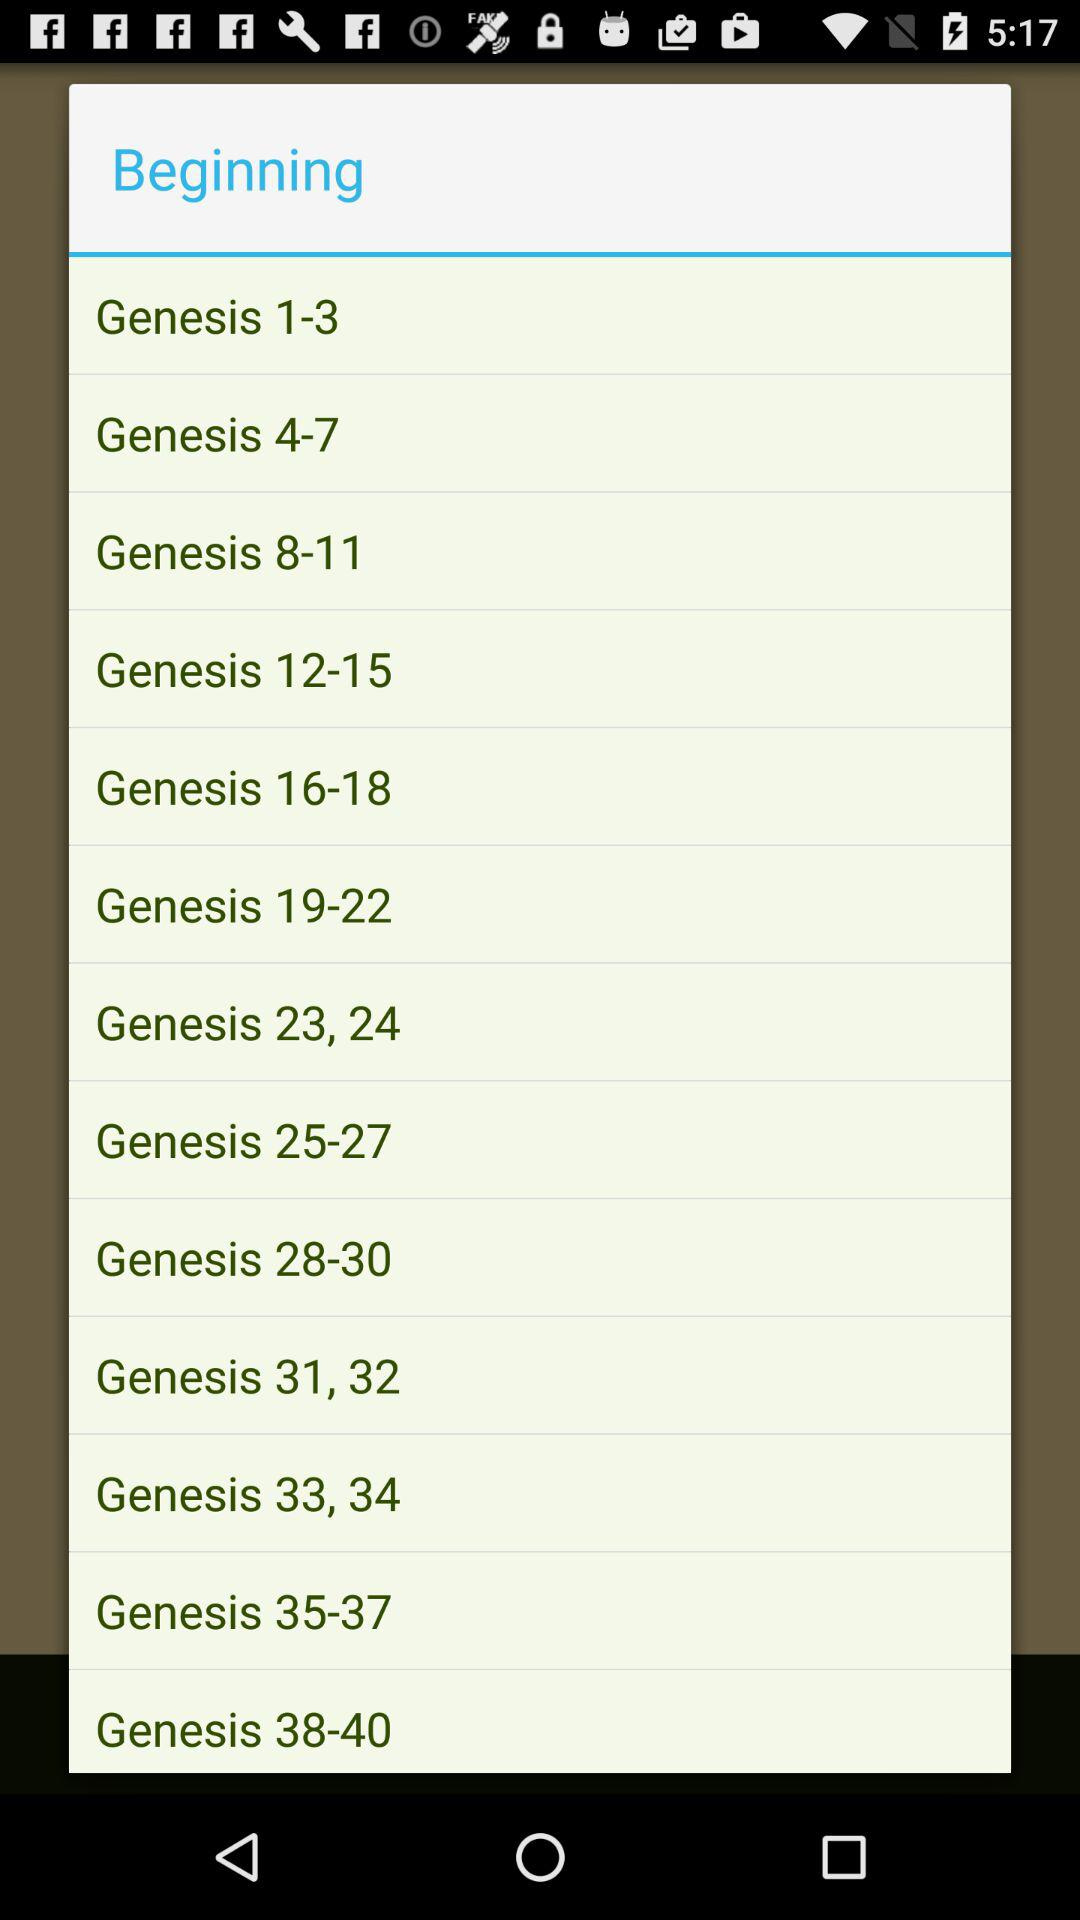How many chapters are in the Genesis book?
Answer the question using a single word or phrase. 40 